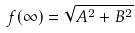<formula> <loc_0><loc_0><loc_500><loc_500>f ( \infty ) = \sqrt { A ^ { 2 } + B ^ { 2 } }</formula> 